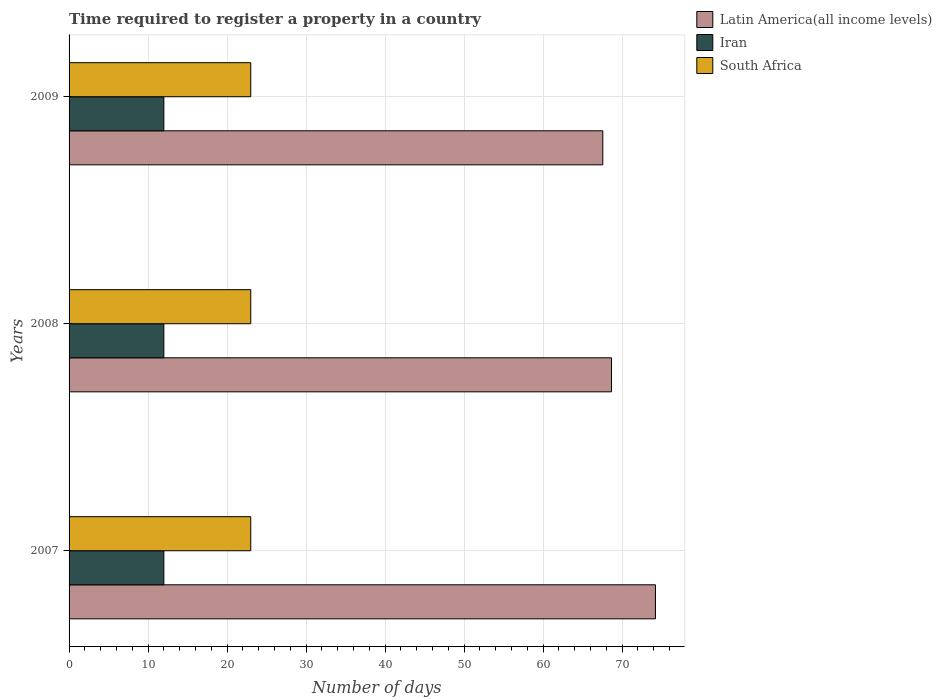How many different coloured bars are there?
Make the answer very short. 3. Are the number of bars per tick equal to the number of legend labels?
Give a very brief answer. Yes. How many bars are there on the 3rd tick from the bottom?
Keep it short and to the point. 3. What is the label of the 2nd group of bars from the top?
Make the answer very short. 2008. What is the number of days required to register a property in Latin America(all income levels) in 2007?
Give a very brief answer. 74.23. Across all years, what is the maximum number of days required to register a property in South Africa?
Keep it short and to the point. 23. Across all years, what is the minimum number of days required to register a property in Latin America(all income levels)?
Ensure brevity in your answer.  67.57. In which year was the number of days required to register a property in South Africa maximum?
Ensure brevity in your answer.  2007. What is the total number of days required to register a property in South Africa in the graph?
Ensure brevity in your answer.  69. What is the difference between the number of days required to register a property in South Africa in 2008 and that in 2009?
Make the answer very short. 0. What is the difference between the number of days required to register a property in South Africa in 2009 and the number of days required to register a property in Iran in 2008?
Give a very brief answer. 11. In the year 2009, what is the difference between the number of days required to register a property in Latin America(all income levels) and number of days required to register a property in South Africa?
Your answer should be compact. 44.57. In how many years, is the number of days required to register a property in South Africa greater than 10 days?
Keep it short and to the point. 3. Is the number of days required to register a property in Latin America(all income levels) in 2008 less than that in 2009?
Your answer should be very brief. No. What is the difference between the highest and the second highest number of days required to register a property in Iran?
Your response must be concise. 0. What is the difference between the highest and the lowest number of days required to register a property in South Africa?
Ensure brevity in your answer.  0. In how many years, is the number of days required to register a property in Iran greater than the average number of days required to register a property in Iran taken over all years?
Your answer should be compact. 0. Is the sum of the number of days required to register a property in Latin America(all income levels) in 2008 and 2009 greater than the maximum number of days required to register a property in South Africa across all years?
Your answer should be very brief. Yes. What does the 2nd bar from the top in 2008 represents?
Give a very brief answer. Iran. What does the 3rd bar from the bottom in 2009 represents?
Your answer should be compact. South Africa. Are all the bars in the graph horizontal?
Your response must be concise. Yes. How are the legend labels stacked?
Ensure brevity in your answer.  Vertical. What is the title of the graph?
Provide a succinct answer. Time required to register a property in a country. What is the label or title of the X-axis?
Keep it short and to the point. Number of days. What is the Number of days of Latin America(all income levels) in 2007?
Make the answer very short. 74.23. What is the Number of days in Iran in 2007?
Provide a short and direct response. 12. What is the Number of days of South Africa in 2007?
Your response must be concise. 23. What is the Number of days in Latin America(all income levels) in 2008?
Make the answer very short. 68.67. What is the Number of days in Iran in 2008?
Give a very brief answer. 12. What is the Number of days in Latin America(all income levels) in 2009?
Ensure brevity in your answer.  67.57. What is the Number of days of Iran in 2009?
Provide a succinct answer. 12. Across all years, what is the maximum Number of days of Latin America(all income levels)?
Offer a terse response. 74.23. Across all years, what is the minimum Number of days of Latin America(all income levels)?
Offer a terse response. 67.57. Across all years, what is the minimum Number of days in Iran?
Your answer should be very brief. 12. What is the total Number of days of Latin America(all income levels) in the graph?
Give a very brief answer. 210.47. What is the total Number of days in Iran in the graph?
Provide a short and direct response. 36. What is the total Number of days of South Africa in the graph?
Ensure brevity in your answer.  69. What is the difference between the Number of days in Latin America(all income levels) in 2007 and that in 2008?
Your answer should be very brief. 5.57. What is the difference between the Number of days in Latin America(all income levels) in 2007 and that in 2009?
Make the answer very short. 6.67. What is the difference between the Number of days in Iran in 2007 and that in 2009?
Give a very brief answer. 0. What is the difference between the Number of days of Iran in 2008 and that in 2009?
Your answer should be compact. 0. What is the difference between the Number of days of South Africa in 2008 and that in 2009?
Your answer should be very brief. 0. What is the difference between the Number of days in Latin America(all income levels) in 2007 and the Number of days in Iran in 2008?
Give a very brief answer. 62.23. What is the difference between the Number of days in Latin America(all income levels) in 2007 and the Number of days in South Africa in 2008?
Offer a very short reply. 51.23. What is the difference between the Number of days of Iran in 2007 and the Number of days of South Africa in 2008?
Give a very brief answer. -11. What is the difference between the Number of days in Latin America(all income levels) in 2007 and the Number of days in Iran in 2009?
Give a very brief answer. 62.23. What is the difference between the Number of days of Latin America(all income levels) in 2007 and the Number of days of South Africa in 2009?
Ensure brevity in your answer.  51.23. What is the difference between the Number of days of Iran in 2007 and the Number of days of South Africa in 2009?
Your response must be concise. -11. What is the difference between the Number of days in Latin America(all income levels) in 2008 and the Number of days in Iran in 2009?
Your response must be concise. 56.67. What is the difference between the Number of days in Latin America(all income levels) in 2008 and the Number of days in South Africa in 2009?
Offer a terse response. 45.67. What is the difference between the Number of days in Iran in 2008 and the Number of days in South Africa in 2009?
Provide a succinct answer. -11. What is the average Number of days of Latin America(all income levels) per year?
Your answer should be compact. 70.16. What is the average Number of days in South Africa per year?
Make the answer very short. 23. In the year 2007, what is the difference between the Number of days of Latin America(all income levels) and Number of days of Iran?
Offer a very short reply. 62.23. In the year 2007, what is the difference between the Number of days in Latin America(all income levels) and Number of days in South Africa?
Offer a very short reply. 51.23. In the year 2008, what is the difference between the Number of days in Latin America(all income levels) and Number of days in Iran?
Offer a very short reply. 56.67. In the year 2008, what is the difference between the Number of days in Latin America(all income levels) and Number of days in South Africa?
Ensure brevity in your answer.  45.67. In the year 2008, what is the difference between the Number of days of Iran and Number of days of South Africa?
Your response must be concise. -11. In the year 2009, what is the difference between the Number of days of Latin America(all income levels) and Number of days of Iran?
Ensure brevity in your answer.  55.57. In the year 2009, what is the difference between the Number of days in Latin America(all income levels) and Number of days in South Africa?
Your answer should be compact. 44.57. What is the ratio of the Number of days in Latin America(all income levels) in 2007 to that in 2008?
Your answer should be compact. 1.08. What is the ratio of the Number of days in Iran in 2007 to that in 2008?
Ensure brevity in your answer.  1. What is the ratio of the Number of days in Latin America(all income levels) in 2007 to that in 2009?
Your answer should be very brief. 1.1. What is the ratio of the Number of days in Iran in 2007 to that in 2009?
Make the answer very short. 1. What is the ratio of the Number of days in South Africa in 2007 to that in 2009?
Keep it short and to the point. 1. What is the ratio of the Number of days of Latin America(all income levels) in 2008 to that in 2009?
Your response must be concise. 1.02. What is the difference between the highest and the second highest Number of days of Latin America(all income levels)?
Keep it short and to the point. 5.57. What is the difference between the highest and the lowest Number of days in Latin America(all income levels)?
Offer a terse response. 6.67. 